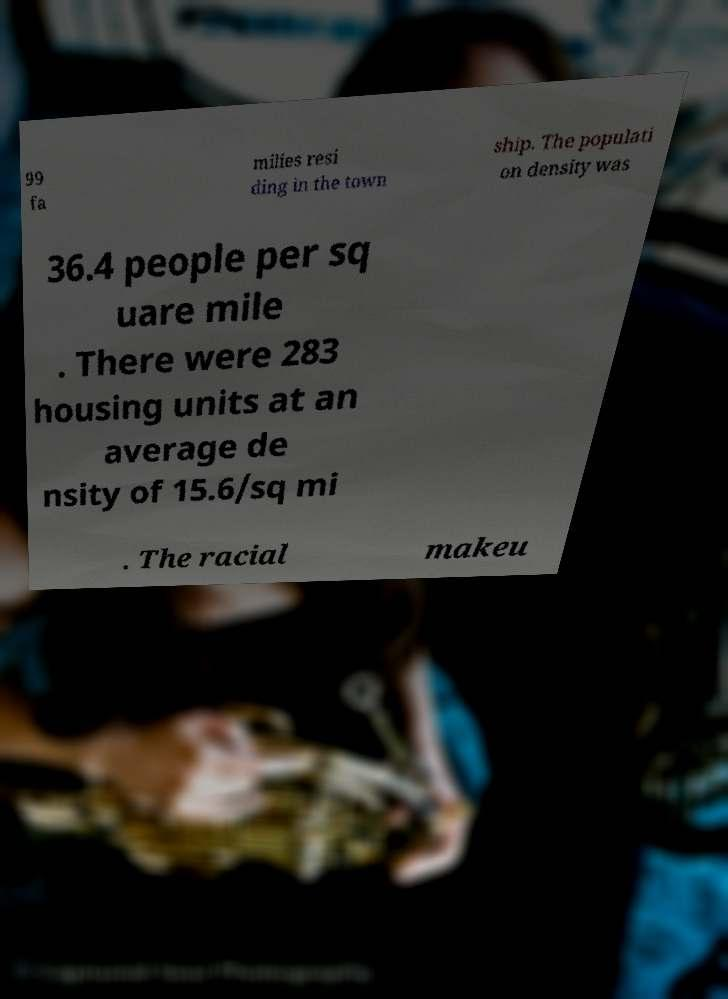There's text embedded in this image that I need extracted. Can you transcribe it verbatim? 99 fa milies resi ding in the town ship. The populati on density was 36.4 people per sq uare mile . There were 283 housing units at an average de nsity of 15.6/sq mi . The racial makeu 